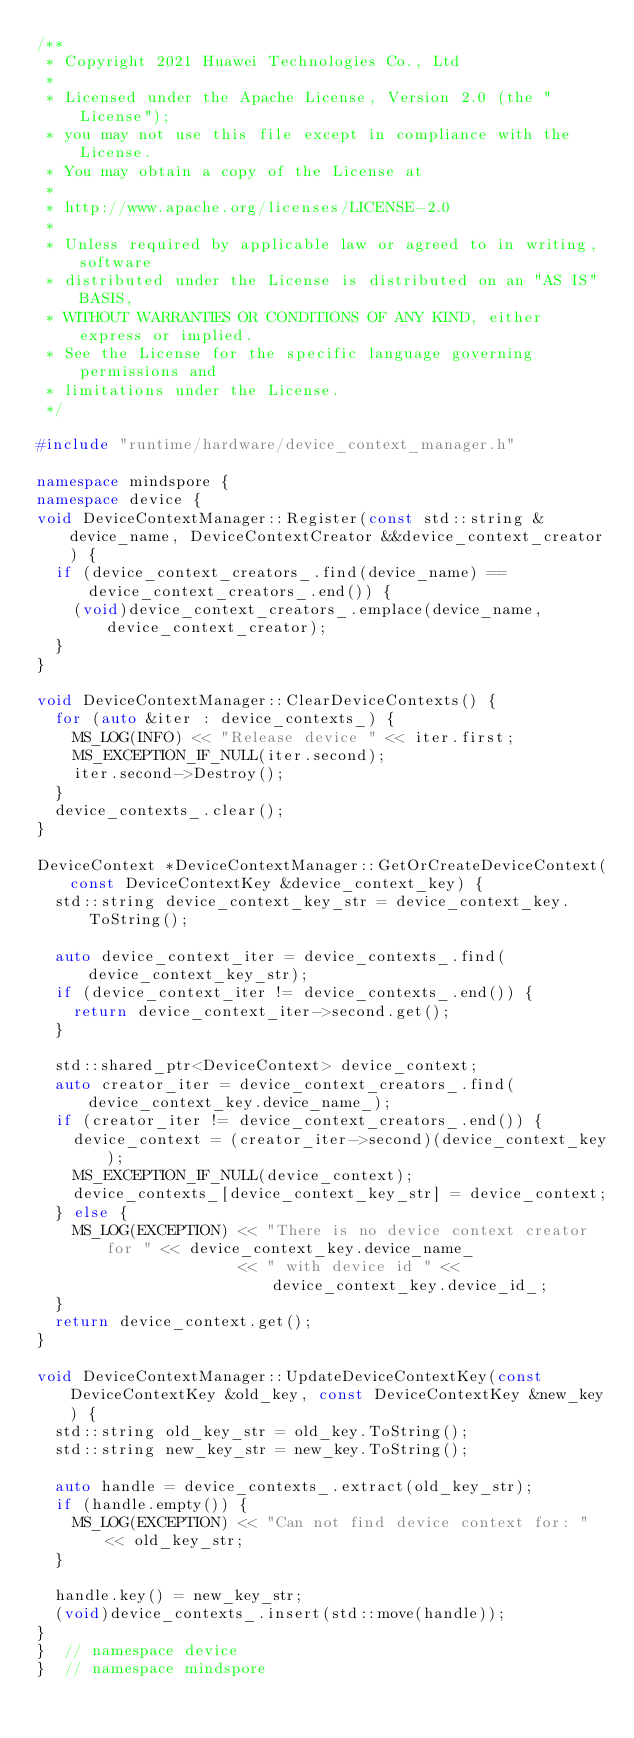Convert code to text. <code><loc_0><loc_0><loc_500><loc_500><_C++_>/**
 * Copyright 2021 Huawei Technologies Co., Ltd
 *
 * Licensed under the Apache License, Version 2.0 (the "License");
 * you may not use this file except in compliance with the License.
 * You may obtain a copy of the License at
 *
 * http://www.apache.org/licenses/LICENSE-2.0
 *
 * Unless required by applicable law or agreed to in writing, software
 * distributed under the License is distributed on an "AS IS" BASIS,
 * WITHOUT WARRANTIES OR CONDITIONS OF ANY KIND, either express or implied.
 * See the License for the specific language governing permissions and
 * limitations under the License.
 */

#include "runtime/hardware/device_context_manager.h"

namespace mindspore {
namespace device {
void DeviceContextManager::Register(const std::string &device_name, DeviceContextCreator &&device_context_creator) {
  if (device_context_creators_.find(device_name) == device_context_creators_.end()) {
    (void)device_context_creators_.emplace(device_name, device_context_creator);
  }
}

void DeviceContextManager::ClearDeviceContexts() {
  for (auto &iter : device_contexts_) {
    MS_LOG(INFO) << "Release device " << iter.first;
    MS_EXCEPTION_IF_NULL(iter.second);
    iter.second->Destroy();
  }
  device_contexts_.clear();
}

DeviceContext *DeviceContextManager::GetOrCreateDeviceContext(const DeviceContextKey &device_context_key) {
  std::string device_context_key_str = device_context_key.ToString();

  auto device_context_iter = device_contexts_.find(device_context_key_str);
  if (device_context_iter != device_contexts_.end()) {
    return device_context_iter->second.get();
  }

  std::shared_ptr<DeviceContext> device_context;
  auto creator_iter = device_context_creators_.find(device_context_key.device_name_);
  if (creator_iter != device_context_creators_.end()) {
    device_context = (creator_iter->second)(device_context_key);
    MS_EXCEPTION_IF_NULL(device_context);
    device_contexts_[device_context_key_str] = device_context;
  } else {
    MS_LOG(EXCEPTION) << "There is no device context creator for " << device_context_key.device_name_
                      << " with device id " << device_context_key.device_id_;
  }
  return device_context.get();
}

void DeviceContextManager::UpdateDeviceContextKey(const DeviceContextKey &old_key, const DeviceContextKey &new_key) {
  std::string old_key_str = old_key.ToString();
  std::string new_key_str = new_key.ToString();

  auto handle = device_contexts_.extract(old_key_str);
  if (handle.empty()) {
    MS_LOG(EXCEPTION) << "Can not find device context for: " << old_key_str;
  }

  handle.key() = new_key_str;
  (void)device_contexts_.insert(std::move(handle));
}
}  // namespace device
}  // namespace mindspore
</code> 